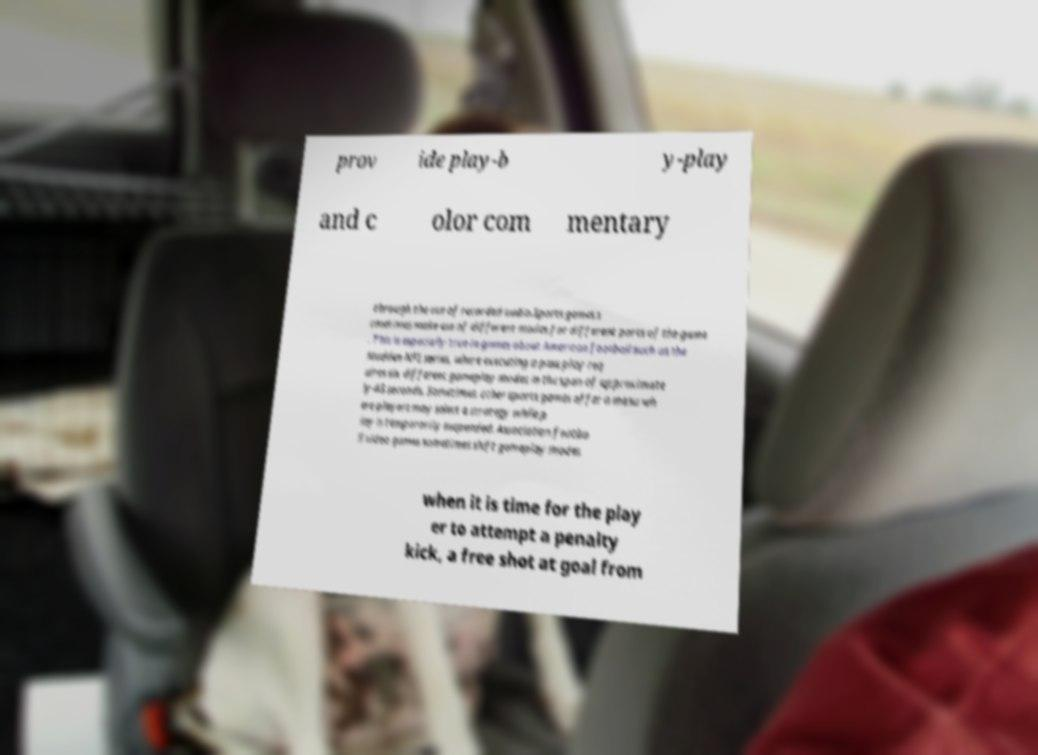Could you assist in decoding the text presented in this image and type it out clearly? prov ide play-b y-play and c olor com mentary through the use of recorded audio.Sports games s ometimes make use of different modes for different parts of the game . This is especially true in games about American football such as the Madden NFL series, where executing a pass play req uires six different gameplay modes in the span of approximate ly 45 seconds. Sometimes, other sports games offer a menu wh ere players may select a strategy while p lay is temporarily suspended. Association footba ll video games sometimes shift gameplay modes when it is time for the play er to attempt a penalty kick, a free shot at goal from 